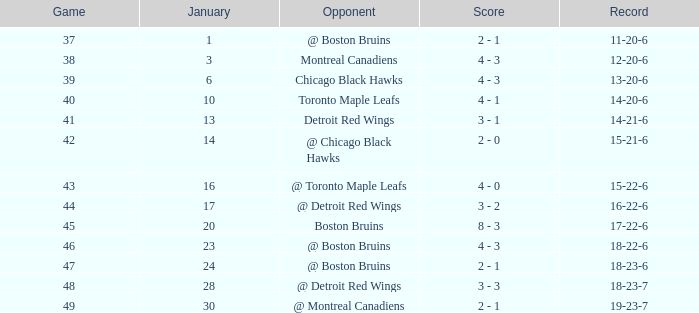Which day in january witnessed a game with more than 49 points and the montreal canadiens as the rival team? None. 